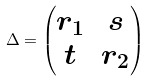<formula> <loc_0><loc_0><loc_500><loc_500>\Delta = \begin{pmatrix} r _ { 1 } & s \\ t & r _ { 2 } \end{pmatrix}</formula> 